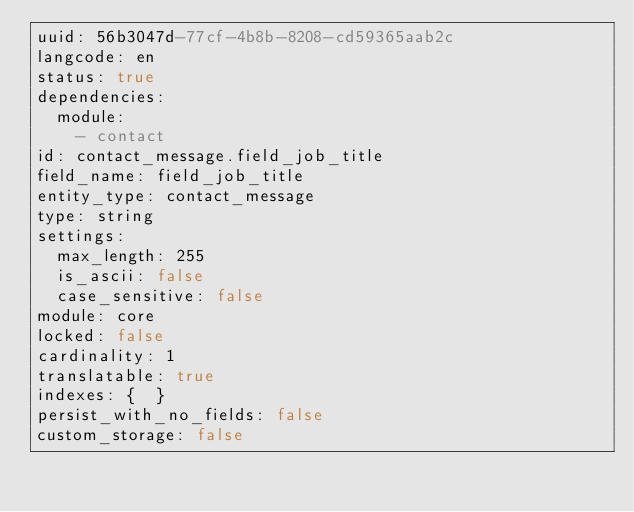<code> <loc_0><loc_0><loc_500><loc_500><_YAML_>uuid: 56b3047d-77cf-4b8b-8208-cd59365aab2c
langcode: en
status: true
dependencies:
  module:
    - contact
id: contact_message.field_job_title
field_name: field_job_title
entity_type: contact_message
type: string
settings:
  max_length: 255
  is_ascii: false
  case_sensitive: false
module: core
locked: false
cardinality: 1
translatable: true
indexes: {  }
persist_with_no_fields: false
custom_storage: false
</code> 